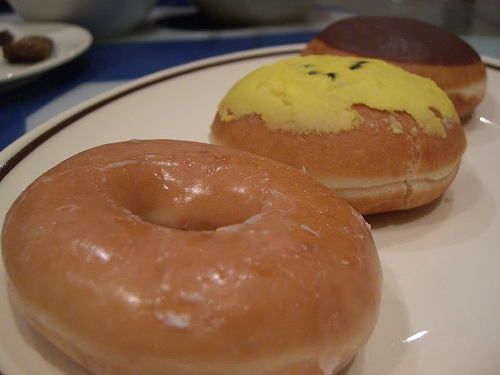<image>How many calories are in just one of these doughnuts? It's unknown how many calories are in just one of these doughnuts. The estimations vary widely. How many calories are in just one of these doughnuts? It is unknown how many calories are in just one of these doughnuts. 